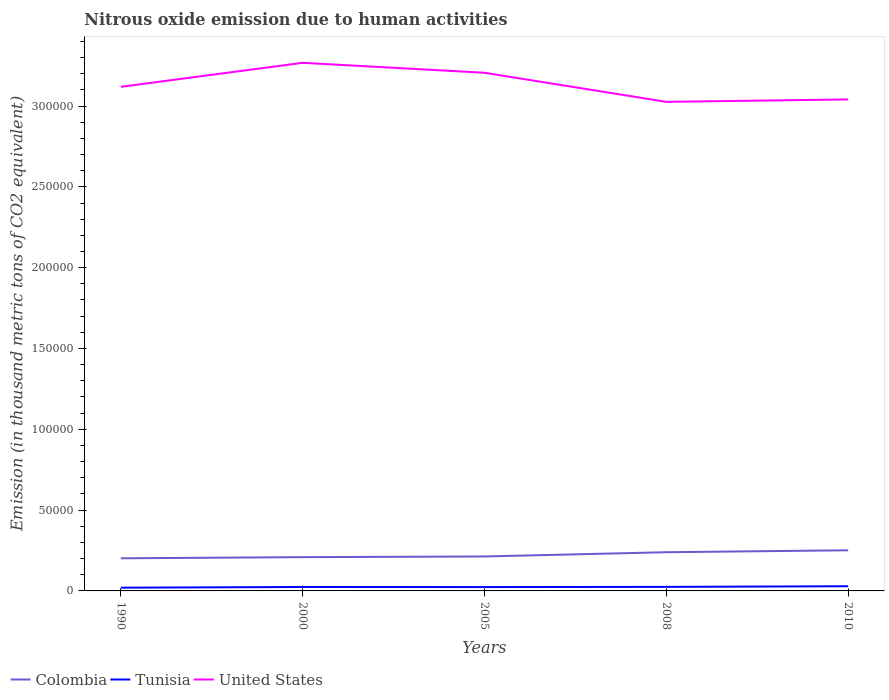How many different coloured lines are there?
Provide a short and direct response. 3. Does the line corresponding to United States intersect with the line corresponding to Tunisia?
Ensure brevity in your answer.  No. Across all years, what is the maximum amount of nitrous oxide emitted in United States?
Your answer should be very brief. 3.03e+05. In which year was the amount of nitrous oxide emitted in Tunisia maximum?
Offer a very short reply. 1990. What is the total amount of nitrous oxide emitted in Tunisia in the graph?
Your answer should be very brief. -902.8. What is the difference between the highest and the second highest amount of nitrous oxide emitted in Tunisia?
Your response must be concise. 902.8. Is the amount of nitrous oxide emitted in Colombia strictly greater than the amount of nitrous oxide emitted in United States over the years?
Your response must be concise. Yes. How many lines are there?
Your response must be concise. 3. How many years are there in the graph?
Your answer should be very brief. 5. Does the graph contain grids?
Offer a very short reply. No. How many legend labels are there?
Offer a very short reply. 3. How are the legend labels stacked?
Provide a short and direct response. Horizontal. What is the title of the graph?
Provide a succinct answer. Nitrous oxide emission due to human activities. What is the label or title of the X-axis?
Give a very brief answer. Years. What is the label or title of the Y-axis?
Offer a very short reply. Emission (in thousand metric tons of CO2 equivalent). What is the Emission (in thousand metric tons of CO2 equivalent) in Colombia in 1990?
Offer a terse response. 2.02e+04. What is the Emission (in thousand metric tons of CO2 equivalent) of Tunisia in 1990?
Ensure brevity in your answer.  2001.7. What is the Emission (in thousand metric tons of CO2 equivalent) in United States in 1990?
Your answer should be very brief. 3.12e+05. What is the Emission (in thousand metric tons of CO2 equivalent) of Colombia in 2000?
Provide a short and direct response. 2.09e+04. What is the Emission (in thousand metric tons of CO2 equivalent) of Tunisia in 2000?
Provide a short and direct response. 2436.9. What is the Emission (in thousand metric tons of CO2 equivalent) of United States in 2000?
Provide a succinct answer. 3.27e+05. What is the Emission (in thousand metric tons of CO2 equivalent) in Colombia in 2005?
Provide a short and direct response. 2.13e+04. What is the Emission (in thousand metric tons of CO2 equivalent) in Tunisia in 2005?
Provide a short and direct response. 2379.7. What is the Emission (in thousand metric tons of CO2 equivalent) in United States in 2005?
Offer a terse response. 3.21e+05. What is the Emission (in thousand metric tons of CO2 equivalent) of Colombia in 2008?
Give a very brief answer. 2.39e+04. What is the Emission (in thousand metric tons of CO2 equivalent) in Tunisia in 2008?
Ensure brevity in your answer.  2506.4. What is the Emission (in thousand metric tons of CO2 equivalent) in United States in 2008?
Make the answer very short. 3.03e+05. What is the Emission (in thousand metric tons of CO2 equivalent) of Colombia in 2010?
Provide a short and direct response. 2.51e+04. What is the Emission (in thousand metric tons of CO2 equivalent) in Tunisia in 2010?
Keep it short and to the point. 2904.5. What is the Emission (in thousand metric tons of CO2 equivalent) in United States in 2010?
Give a very brief answer. 3.04e+05. Across all years, what is the maximum Emission (in thousand metric tons of CO2 equivalent) in Colombia?
Ensure brevity in your answer.  2.51e+04. Across all years, what is the maximum Emission (in thousand metric tons of CO2 equivalent) of Tunisia?
Give a very brief answer. 2904.5. Across all years, what is the maximum Emission (in thousand metric tons of CO2 equivalent) of United States?
Your answer should be very brief. 3.27e+05. Across all years, what is the minimum Emission (in thousand metric tons of CO2 equivalent) in Colombia?
Ensure brevity in your answer.  2.02e+04. Across all years, what is the minimum Emission (in thousand metric tons of CO2 equivalent) of Tunisia?
Provide a short and direct response. 2001.7. Across all years, what is the minimum Emission (in thousand metric tons of CO2 equivalent) of United States?
Your answer should be compact. 3.03e+05. What is the total Emission (in thousand metric tons of CO2 equivalent) of Colombia in the graph?
Provide a short and direct response. 1.11e+05. What is the total Emission (in thousand metric tons of CO2 equivalent) in Tunisia in the graph?
Give a very brief answer. 1.22e+04. What is the total Emission (in thousand metric tons of CO2 equivalent) in United States in the graph?
Your answer should be very brief. 1.57e+06. What is the difference between the Emission (in thousand metric tons of CO2 equivalent) in Colombia in 1990 and that in 2000?
Give a very brief answer. -706.7. What is the difference between the Emission (in thousand metric tons of CO2 equivalent) in Tunisia in 1990 and that in 2000?
Provide a short and direct response. -435.2. What is the difference between the Emission (in thousand metric tons of CO2 equivalent) of United States in 1990 and that in 2000?
Offer a terse response. -1.49e+04. What is the difference between the Emission (in thousand metric tons of CO2 equivalent) in Colombia in 1990 and that in 2005?
Make the answer very short. -1134.8. What is the difference between the Emission (in thousand metric tons of CO2 equivalent) in Tunisia in 1990 and that in 2005?
Provide a short and direct response. -378. What is the difference between the Emission (in thousand metric tons of CO2 equivalent) in United States in 1990 and that in 2005?
Give a very brief answer. -8707.9. What is the difference between the Emission (in thousand metric tons of CO2 equivalent) in Colombia in 1990 and that in 2008?
Give a very brief answer. -3767.8. What is the difference between the Emission (in thousand metric tons of CO2 equivalent) in Tunisia in 1990 and that in 2008?
Your answer should be very brief. -504.7. What is the difference between the Emission (in thousand metric tons of CO2 equivalent) of United States in 1990 and that in 2008?
Give a very brief answer. 9292.3. What is the difference between the Emission (in thousand metric tons of CO2 equivalent) of Colombia in 1990 and that in 2010?
Give a very brief answer. -4960.2. What is the difference between the Emission (in thousand metric tons of CO2 equivalent) of Tunisia in 1990 and that in 2010?
Provide a succinct answer. -902.8. What is the difference between the Emission (in thousand metric tons of CO2 equivalent) of United States in 1990 and that in 2010?
Make the answer very short. 7806.5. What is the difference between the Emission (in thousand metric tons of CO2 equivalent) in Colombia in 2000 and that in 2005?
Offer a very short reply. -428.1. What is the difference between the Emission (in thousand metric tons of CO2 equivalent) of Tunisia in 2000 and that in 2005?
Ensure brevity in your answer.  57.2. What is the difference between the Emission (in thousand metric tons of CO2 equivalent) in United States in 2000 and that in 2005?
Provide a succinct answer. 6144.9. What is the difference between the Emission (in thousand metric tons of CO2 equivalent) of Colombia in 2000 and that in 2008?
Provide a succinct answer. -3061.1. What is the difference between the Emission (in thousand metric tons of CO2 equivalent) of Tunisia in 2000 and that in 2008?
Your answer should be compact. -69.5. What is the difference between the Emission (in thousand metric tons of CO2 equivalent) of United States in 2000 and that in 2008?
Your answer should be very brief. 2.41e+04. What is the difference between the Emission (in thousand metric tons of CO2 equivalent) in Colombia in 2000 and that in 2010?
Provide a succinct answer. -4253.5. What is the difference between the Emission (in thousand metric tons of CO2 equivalent) of Tunisia in 2000 and that in 2010?
Offer a very short reply. -467.6. What is the difference between the Emission (in thousand metric tons of CO2 equivalent) in United States in 2000 and that in 2010?
Give a very brief answer. 2.27e+04. What is the difference between the Emission (in thousand metric tons of CO2 equivalent) in Colombia in 2005 and that in 2008?
Keep it short and to the point. -2633. What is the difference between the Emission (in thousand metric tons of CO2 equivalent) of Tunisia in 2005 and that in 2008?
Make the answer very short. -126.7. What is the difference between the Emission (in thousand metric tons of CO2 equivalent) of United States in 2005 and that in 2008?
Your answer should be compact. 1.80e+04. What is the difference between the Emission (in thousand metric tons of CO2 equivalent) of Colombia in 2005 and that in 2010?
Keep it short and to the point. -3825.4. What is the difference between the Emission (in thousand metric tons of CO2 equivalent) of Tunisia in 2005 and that in 2010?
Ensure brevity in your answer.  -524.8. What is the difference between the Emission (in thousand metric tons of CO2 equivalent) in United States in 2005 and that in 2010?
Offer a very short reply. 1.65e+04. What is the difference between the Emission (in thousand metric tons of CO2 equivalent) of Colombia in 2008 and that in 2010?
Your answer should be very brief. -1192.4. What is the difference between the Emission (in thousand metric tons of CO2 equivalent) of Tunisia in 2008 and that in 2010?
Provide a succinct answer. -398.1. What is the difference between the Emission (in thousand metric tons of CO2 equivalent) of United States in 2008 and that in 2010?
Provide a short and direct response. -1485.8. What is the difference between the Emission (in thousand metric tons of CO2 equivalent) of Colombia in 1990 and the Emission (in thousand metric tons of CO2 equivalent) of Tunisia in 2000?
Make the answer very short. 1.77e+04. What is the difference between the Emission (in thousand metric tons of CO2 equivalent) of Colombia in 1990 and the Emission (in thousand metric tons of CO2 equivalent) of United States in 2000?
Offer a very short reply. -3.07e+05. What is the difference between the Emission (in thousand metric tons of CO2 equivalent) in Tunisia in 1990 and the Emission (in thousand metric tons of CO2 equivalent) in United States in 2000?
Provide a succinct answer. -3.25e+05. What is the difference between the Emission (in thousand metric tons of CO2 equivalent) in Colombia in 1990 and the Emission (in thousand metric tons of CO2 equivalent) in Tunisia in 2005?
Offer a terse response. 1.78e+04. What is the difference between the Emission (in thousand metric tons of CO2 equivalent) in Colombia in 1990 and the Emission (in thousand metric tons of CO2 equivalent) in United States in 2005?
Make the answer very short. -3.00e+05. What is the difference between the Emission (in thousand metric tons of CO2 equivalent) in Tunisia in 1990 and the Emission (in thousand metric tons of CO2 equivalent) in United States in 2005?
Provide a short and direct response. -3.19e+05. What is the difference between the Emission (in thousand metric tons of CO2 equivalent) of Colombia in 1990 and the Emission (in thousand metric tons of CO2 equivalent) of Tunisia in 2008?
Provide a short and direct response. 1.77e+04. What is the difference between the Emission (in thousand metric tons of CO2 equivalent) in Colombia in 1990 and the Emission (in thousand metric tons of CO2 equivalent) in United States in 2008?
Provide a short and direct response. -2.82e+05. What is the difference between the Emission (in thousand metric tons of CO2 equivalent) in Tunisia in 1990 and the Emission (in thousand metric tons of CO2 equivalent) in United States in 2008?
Offer a terse response. -3.01e+05. What is the difference between the Emission (in thousand metric tons of CO2 equivalent) in Colombia in 1990 and the Emission (in thousand metric tons of CO2 equivalent) in Tunisia in 2010?
Keep it short and to the point. 1.73e+04. What is the difference between the Emission (in thousand metric tons of CO2 equivalent) in Colombia in 1990 and the Emission (in thousand metric tons of CO2 equivalent) in United States in 2010?
Make the answer very short. -2.84e+05. What is the difference between the Emission (in thousand metric tons of CO2 equivalent) of Tunisia in 1990 and the Emission (in thousand metric tons of CO2 equivalent) of United States in 2010?
Provide a succinct answer. -3.02e+05. What is the difference between the Emission (in thousand metric tons of CO2 equivalent) in Colombia in 2000 and the Emission (in thousand metric tons of CO2 equivalent) in Tunisia in 2005?
Provide a succinct answer. 1.85e+04. What is the difference between the Emission (in thousand metric tons of CO2 equivalent) in Colombia in 2000 and the Emission (in thousand metric tons of CO2 equivalent) in United States in 2005?
Keep it short and to the point. -3.00e+05. What is the difference between the Emission (in thousand metric tons of CO2 equivalent) of Tunisia in 2000 and the Emission (in thousand metric tons of CO2 equivalent) of United States in 2005?
Offer a very short reply. -3.18e+05. What is the difference between the Emission (in thousand metric tons of CO2 equivalent) of Colombia in 2000 and the Emission (in thousand metric tons of CO2 equivalent) of Tunisia in 2008?
Your response must be concise. 1.84e+04. What is the difference between the Emission (in thousand metric tons of CO2 equivalent) in Colombia in 2000 and the Emission (in thousand metric tons of CO2 equivalent) in United States in 2008?
Provide a succinct answer. -2.82e+05. What is the difference between the Emission (in thousand metric tons of CO2 equivalent) in Tunisia in 2000 and the Emission (in thousand metric tons of CO2 equivalent) in United States in 2008?
Your answer should be compact. -3.00e+05. What is the difference between the Emission (in thousand metric tons of CO2 equivalent) in Colombia in 2000 and the Emission (in thousand metric tons of CO2 equivalent) in Tunisia in 2010?
Provide a short and direct response. 1.80e+04. What is the difference between the Emission (in thousand metric tons of CO2 equivalent) in Colombia in 2000 and the Emission (in thousand metric tons of CO2 equivalent) in United States in 2010?
Provide a short and direct response. -2.83e+05. What is the difference between the Emission (in thousand metric tons of CO2 equivalent) in Tunisia in 2000 and the Emission (in thousand metric tons of CO2 equivalent) in United States in 2010?
Your answer should be compact. -3.02e+05. What is the difference between the Emission (in thousand metric tons of CO2 equivalent) of Colombia in 2005 and the Emission (in thousand metric tons of CO2 equivalent) of Tunisia in 2008?
Make the answer very short. 1.88e+04. What is the difference between the Emission (in thousand metric tons of CO2 equivalent) in Colombia in 2005 and the Emission (in thousand metric tons of CO2 equivalent) in United States in 2008?
Provide a succinct answer. -2.81e+05. What is the difference between the Emission (in thousand metric tons of CO2 equivalent) in Tunisia in 2005 and the Emission (in thousand metric tons of CO2 equivalent) in United States in 2008?
Make the answer very short. -3.00e+05. What is the difference between the Emission (in thousand metric tons of CO2 equivalent) of Colombia in 2005 and the Emission (in thousand metric tons of CO2 equivalent) of Tunisia in 2010?
Provide a succinct answer. 1.84e+04. What is the difference between the Emission (in thousand metric tons of CO2 equivalent) in Colombia in 2005 and the Emission (in thousand metric tons of CO2 equivalent) in United States in 2010?
Provide a short and direct response. -2.83e+05. What is the difference between the Emission (in thousand metric tons of CO2 equivalent) of Tunisia in 2005 and the Emission (in thousand metric tons of CO2 equivalent) of United States in 2010?
Make the answer very short. -3.02e+05. What is the difference between the Emission (in thousand metric tons of CO2 equivalent) in Colombia in 2008 and the Emission (in thousand metric tons of CO2 equivalent) in Tunisia in 2010?
Ensure brevity in your answer.  2.10e+04. What is the difference between the Emission (in thousand metric tons of CO2 equivalent) in Colombia in 2008 and the Emission (in thousand metric tons of CO2 equivalent) in United States in 2010?
Offer a terse response. -2.80e+05. What is the difference between the Emission (in thousand metric tons of CO2 equivalent) of Tunisia in 2008 and the Emission (in thousand metric tons of CO2 equivalent) of United States in 2010?
Offer a terse response. -3.02e+05. What is the average Emission (in thousand metric tons of CO2 equivalent) in Colombia per year?
Ensure brevity in your answer.  2.23e+04. What is the average Emission (in thousand metric tons of CO2 equivalent) in Tunisia per year?
Your response must be concise. 2445.84. What is the average Emission (in thousand metric tons of CO2 equivalent) of United States per year?
Your answer should be compact. 3.13e+05. In the year 1990, what is the difference between the Emission (in thousand metric tons of CO2 equivalent) in Colombia and Emission (in thousand metric tons of CO2 equivalent) in Tunisia?
Your answer should be very brief. 1.82e+04. In the year 1990, what is the difference between the Emission (in thousand metric tons of CO2 equivalent) in Colombia and Emission (in thousand metric tons of CO2 equivalent) in United States?
Offer a very short reply. -2.92e+05. In the year 1990, what is the difference between the Emission (in thousand metric tons of CO2 equivalent) of Tunisia and Emission (in thousand metric tons of CO2 equivalent) of United States?
Your response must be concise. -3.10e+05. In the year 2000, what is the difference between the Emission (in thousand metric tons of CO2 equivalent) in Colombia and Emission (in thousand metric tons of CO2 equivalent) in Tunisia?
Your answer should be very brief. 1.85e+04. In the year 2000, what is the difference between the Emission (in thousand metric tons of CO2 equivalent) in Colombia and Emission (in thousand metric tons of CO2 equivalent) in United States?
Give a very brief answer. -3.06e+05. In the year 2000, what is the difference between the Emission (in thousand metric tons of CO2 equivalent) of Tunisia and Emission (in thousand metric tons of CO2 equivalent) of United States?
Provide a succinct answer. -3.24e+05. In the year 2005, what is the difference between the Emission (in thousand metric tons of CO2 equivalent) of Colombia and Emission (in thousand metric tons of CO2 equivalent) of Tunisia?
Offer a very short reply. 1.89e+04. In the year 2005, what is the difference between the Emission (in thousand metric tons of CO2 equivalent) of Colombia and Emission (in thousand metric tons of CO2 equivalent) of United States?
Your answer should be very brief. -2.99e+05. In the year 2005, what is the difference between the Emission (in thousand metric tons of CO2 equivalent) of Tunisia and Emission (in thousand metric tons of CO2 equivalent) of United States?
Offer a terse response. -3.18e+05. In the year 2008, what is the difference between the Emission (in thousand metric tons of CO2 equivalent) of Colombia and Emission (in thousand metric tons of CO2 equivalent) of Tunisia?
Your answer should be very brief. 2.14e+04. In the year 2008, what is the difference between the Emission (in thousand metric tons of CO2 equivalent) of Colombia and Emission (in thousand metric tons of CO2 equivalent) of United States?
Provide a short and direct response. -2.79e+05. In the year 2008, what is the difference between the Emission (in thousand metric tons of CO2 equivalent) in Tunisia and Emission (in thousand metric tons of CO2 equivalent) in United States?
Give a very brief answer. -3.00e+05. In the year 2010, what is the difference between the Emission (in thousand metric tons of CO2 equivalent) of Colombia and Emission (in thousand metric tons of CO2 equivalent) of Tunisia?
Ensure brevity in your answer.  2.22e+04. In the year 2010, what is the difference between the Emission (in thousand metric tons of CO2 equivalent) of Colombia and Emission (in thousand metric tons of CO2 equivalent) of United States?
Keep it short and to the point. -2.79e+05. In the year 2010, what is the difference between the Emission (in thousand metric tons of CO2 equivalent) in Tunisia and Emission (in thousand metric tons of CO2 equivalent) in United States?
Your answer should be compact. -3.01e+05. What is the ratio of the Emission (in thousand metric tons of CO2 equivalent) in Colombia in 1990 to that in 2000?
Keep it short and to the point. 0.97. What is the ratio of the Emission (in thousand metric tons of CO2 equivalent) of Tunisia in 1990 to that in 2000?
Your answer should be compact. 0.82. What is the ratio of the Emission (in thousand metric tons of CO2 equivalent) in United States in 1990 to that in 2000?
Ensure brevity in your answer.  0.95. What is the ratio of the Emission (in thousand metric tons of CO2 equivalent) of Colombia in 1990 to that in 2005?
Provide a short and direct response. 0.95. What is the ratio of the Emission (in thousand metric tons of CO2 equivalent) of Tunisia in 1990 to that in 2005?
Give a very brief answer. 0.84. What is the ratio of the Emission (in thousand metric tons of CO2 equivalent) of United States in 1990 to that in 2005?
Your answer should be compact. 0.97. What is the ratio of the Emission (in thousand metric tons of CO2 equivalent) of Colombia in 1990 to that in 2008?
Your answer should be very brief. 0.84. What is the ratio of the Emission (in thousand metric tons of CO2 equivalent) in Tunisia in 1990 to that in 2008?
Keep it short and to the point. 0.8. What is the ratio of the Emission (in thousand metric tons of CO2 equivalent) in United States in 1990 to that in 2008?
Offer a very short reply. 1.03. What is the ratio of the Emission (in thousand metric tons of CO2 equivalent) of Colombia in 1990 to that in 2010?
Your response must be concise. 0.8. What is the ratio of the Emission (in thousand metric tons of CO2 equivalent) of Tunisia in 1990 to that in 2010?
Your answer should be compact. 0.69. What is the ratio of the Emission (in thousand metric tons of CO2 equivalent) of United States in 1990 to that in 2010?
Keep it short and to the point. 1.03. What is the ratio of the Emission (in thousand metric tons of CO2 equivalent) of Colombia in 2000 to that in 2005?
Provide a succinct answer. 0.98. What is the ratio of the Emission (in thousand metric tons of CO2 equivalent) of Tunisia in 2000 to that in 2005?
Provide a succinct answer. 1.02. What is the ratio of the Emission (in thousand metric tons of CO2 equivalent) in United States in 2000 to that in 2005?
Offer a terse response. 1.02. What is the ratio of the Emission (in thousand metric tons of CO2 equivalent) in Colombia in 2000 to that in 2008?
Give a very brief answer. 0.87. What is the ratio of the Emission (in thousand metric tons of CO2 equivalent) in Tunisia in 2000 to that in 2008?
Ensure brevity in your answer.  0.97. What is the ratio of the Emission (in thousand metric tons of CO2 equivalent) of United States in 2000 to that in 2008?
Keep it short and to the point. 1.08. What is the ratio of the Emission (in thousand metric tons of CO2 equivalent) in Colombia in 2000 to that in 2010?
Provide a succinct answer. 0.83. What is the ratio of the Emission (in thousand metric tons of CO2 equivalent) in Tunisia in 2000 to that in 2010?
Your answer should be very brief. 0.84. What is the ratio of the Emission (in thousand metric tons of CO2 equivalent) in United States in 2000 to that in 2010?
Offer a terse response. 1.07. What is the ratio of the Emission (in thousand metric tons of CO2 equivalent) in Colombia in 2005 to that in 2008?
Offer a very short reply. 0.89. What is the ratio of the Emission (in thousand metric tons of CO2 equivalent) in Tunisia in 2005 to that in 2008?
Provide a short and direct response. 0.95. What is the ratio of the Emission (in thousand metric tons of CO2 equivalent) in United States in 2005 to that in 2008?
Your response must be concise. 1.06. What is the ratio of the Emission (in thousand metric tons of CO2 equivalent) in Colombia in 2005 to that in 2010?
Offer a terse response. 0.85. What is the ratio of the Emission (in thousand metric tons of CO2 equivalent) in Tunisia in 2005 to that in 2010?
Your answer should be very brief. 0.82. What is the ratio of the Emission (in thousand metric tons of CO2 equivalent) of United States in 2005 to that in 2010?
Your answer should be compact. 1.05. What is the ratio of the Emission (in thousand metric tons of CO2 equivalent) in Colombia in 2008 to that in 2010?
Keep it short and to the point. 0.95. What is the ratio of the Emission (in thousand metric tons of CO2 equivalent) of Tunisia in 2008 to that in 2010?
Offer a terse response. 0.86. What is the difference between the highest and the second highest Emission (in thousand metric tons of CO2 equivalent) in Colombia?
Your answer should be compact. 1192.4. What is the difference between the highest and the second highest Emission (in thousand metric tons of CO2 equivalent) in Tunisia?
Give a very brief answer. 398.1. What is the difference between the highest and the second highest Emission (in thousand metric tons of CO2 equivalent) in United States?
Provide a succinct answer. 6144.9. What is the difference between the highest and the lowest Emission (in thousand metric tons of CO2 equivalent) in Colombia?
Provide a succinct answer. 4960.2. What is the difference between the highest and the lowest Emission (in thousand metric tons of CO2 equivalent) in Tunisia?
Your response must be concise. 902.8. What is the difference between the highest and the lowest Emission (in thousand metric tons of CO2 equivalent) of United States?
Give a very brief answer. 2.41e+04. 